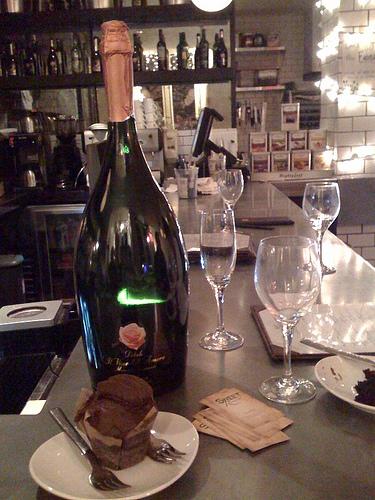Are the goblets empty?
Keep it brief. Yes. What color is the bottle?
Be succinct. Green. Is this a restaurant?
Short answer required. Yes. 